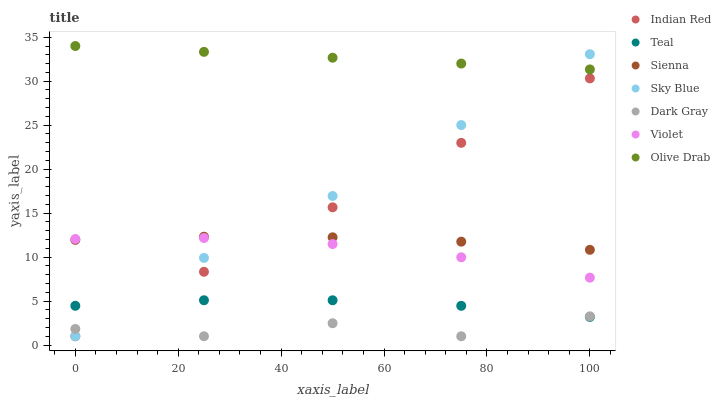Does Dark Gray have the minimum area under the curve?
Answer yes or no. Yes. Does Olive Drab have the maximum area under the curve?
Answer yes or no. Yes. Does Indian Red have the minimum area under the curve?
Answer yes or no. No. Does Indian Red have the maximum area under the curve?
Answer yes or no. No. Is Indian Red the smoothest?
Answer yes or no. Yes. Is Dark Gray the roughest?
Answer yes or no. Yes. Is Sienna the smoothest?
Answer yes or no. No. Is Sienna the roughest?
Answer yes or no. No. Does Dark Gray have the lowest value?
Answer yes or no. Yes. Does Sienna have the lowest value?
Answer yes or no. No. Does Olive Drab have the highest value?
Answer yes or no. Yes. Does Indian Red have the highest value?
Answer yes or no. No. Is Dark Gray less than Olive Drab?
Answer yes or no. Yes. Is Olive Drab greater than Indian Red?
Answer yes or no. Yes. Does Indian Red intersect Dark Gray?
Answer yes or no. Yes. Is Indian Red less than Dark Gray?
Answer yes or no. No. Is Indian Red greater than Dark Gray?
Answer yes or no. No. Does Dark Gray intersect Olive Drab?
Answer yes or no. No. 